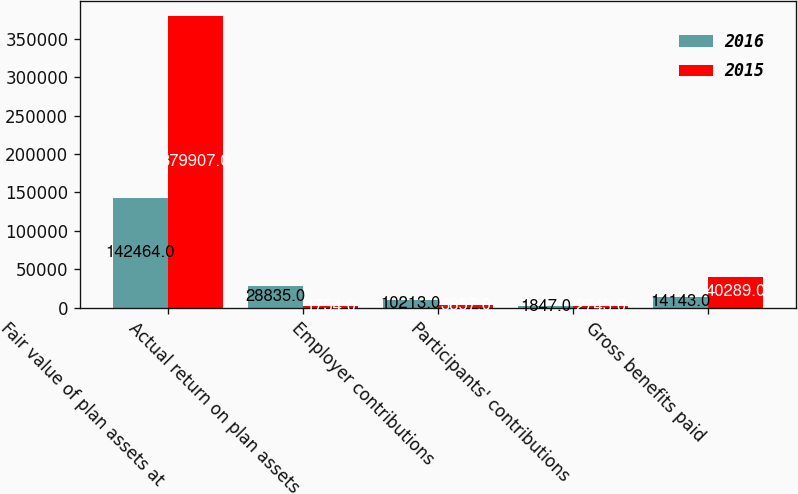<chart> <loc_0><loc_0><loc_500><loc_500><stacked_bar_chart><ecel><fcel>Fair value of plan assets at<fcel>Actual return on plan assets<fcel>Employer contributions<fcel>Participants' contributions<fcel>Gross benefits paid<nl><fcel>2016<fcel>142464<fcel>28835<fcel>10213<fcel>1847<fcel>14143<nl><fcel>2015<fcel>379907<fcel>1754<fcel>3857<fcel>2743<fcel>40289<nl></chart> 